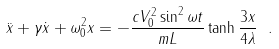<formula> <loc_0><loc_0><loc_500><loc_500>\ddot { x } + \gamma \dot { x } + \omega _ { 0 } ^ { 2 } x = - \frac { c V _ { 0 } ^ { 2 } \sin ^ { 2 } \omega t } { m L } \tanh { \frac { 3 x } { 4 \lambda } } \ .</formula> 